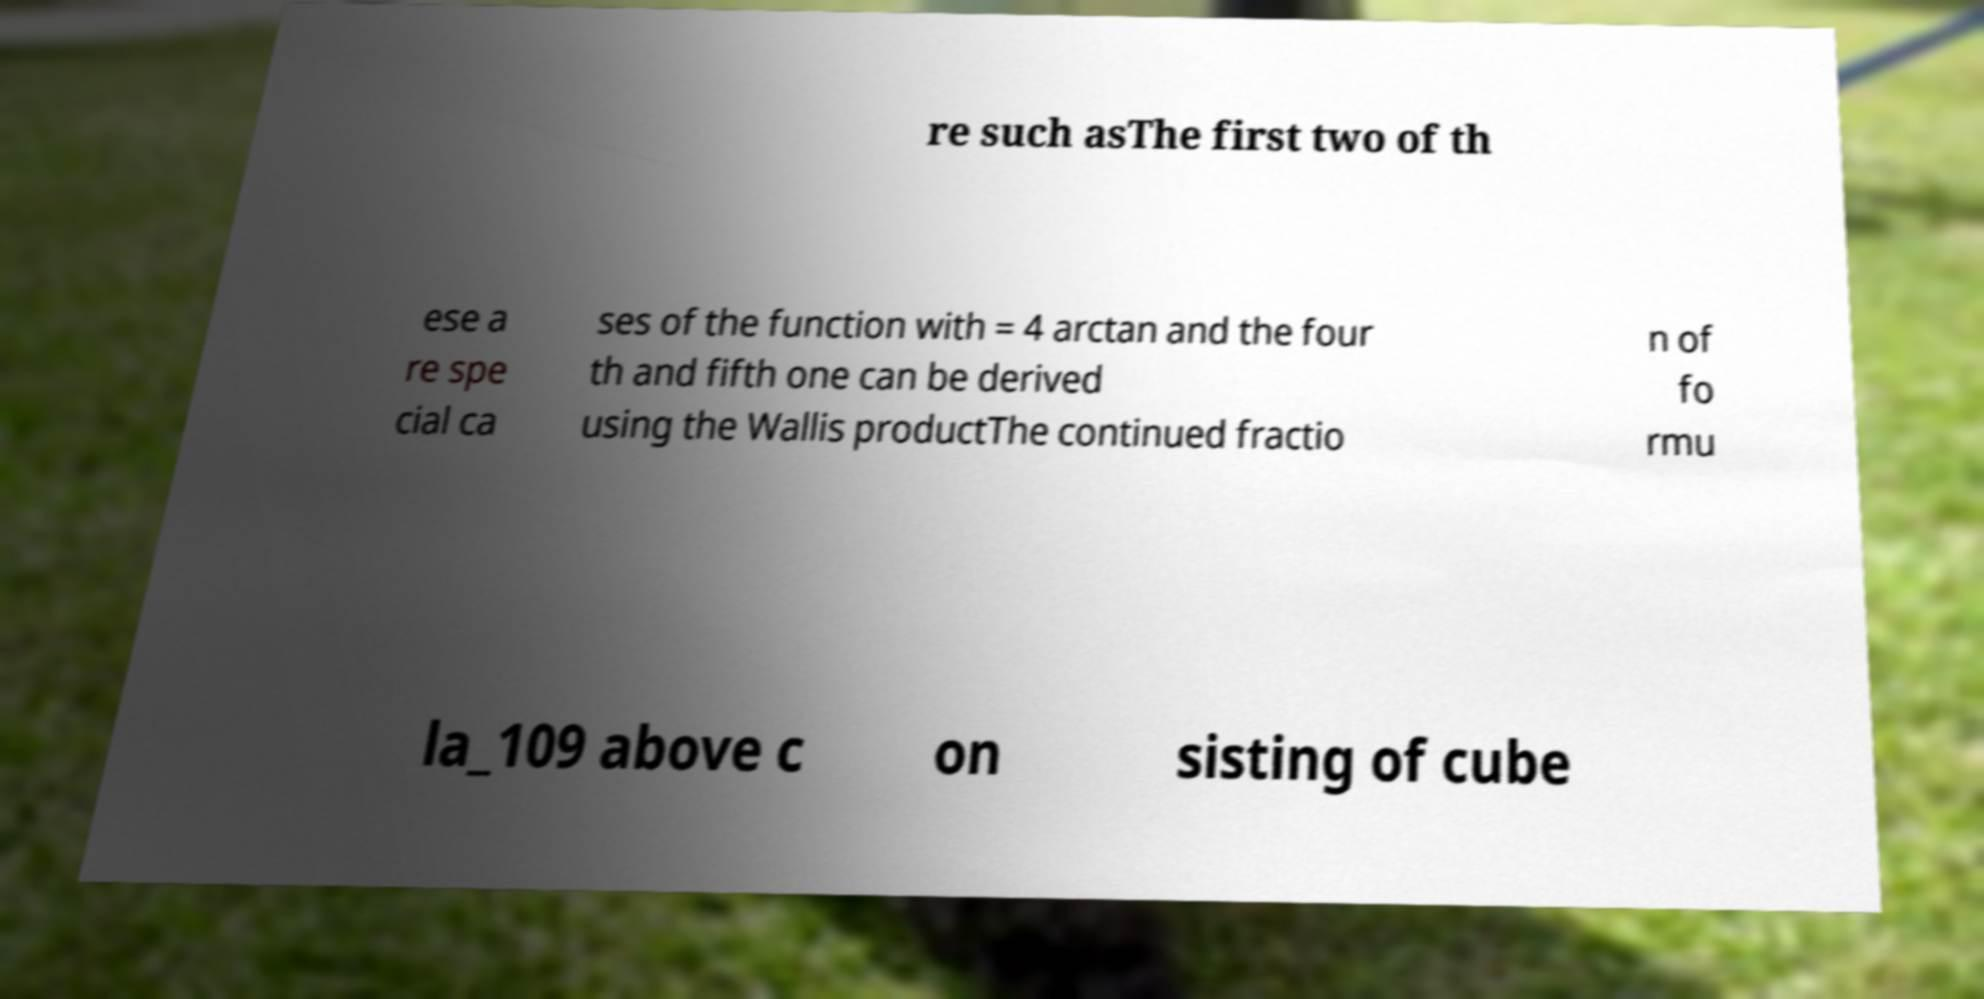There's text embedded in this image that I need extracted. Can you transcribe it verbatim? re such asThe first two of th ese a re spe cial ca ses of the function with = 4 arctan and the four th and fifth one can be derived using the Wallis productThe continued fractio n of fo rmu la_109 above c on sisting of cube 